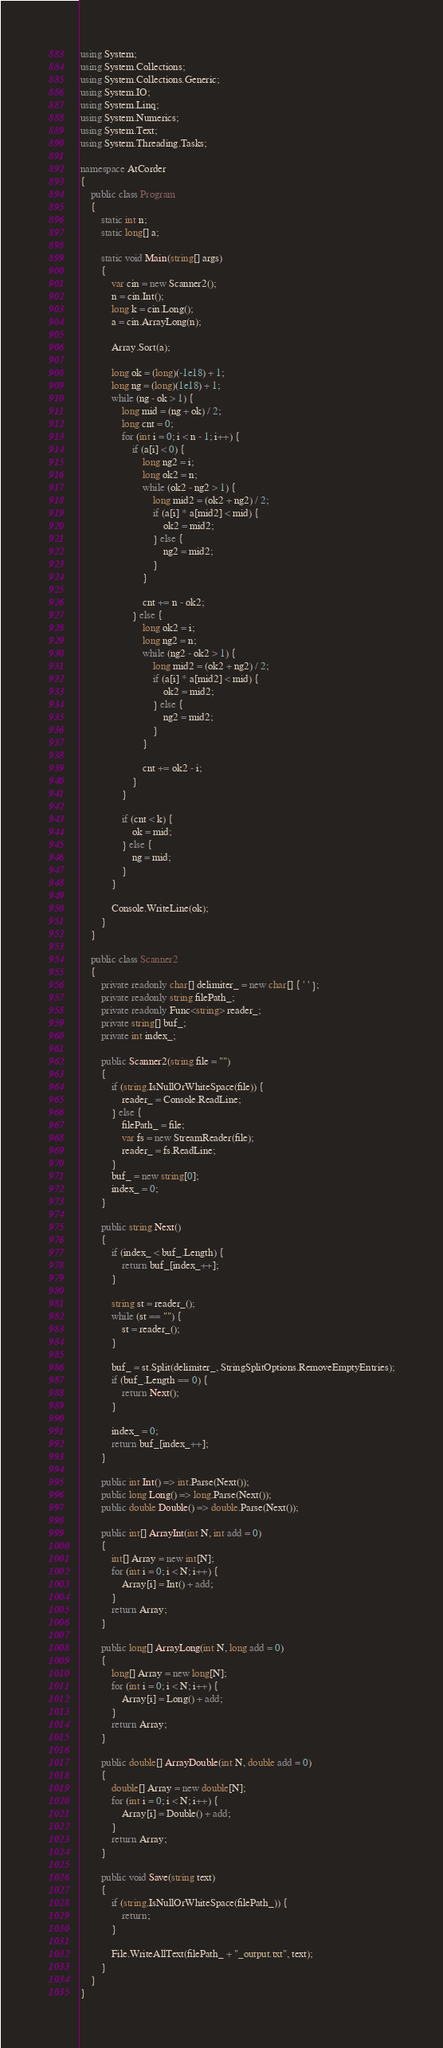<code> <loc_0><loc_0><loc_500><loc_500><_C#_>using System;
using System.Collections;
using System.Collections.Generic;
using System.IO;
using System.Linq;
using System.Numerics;
using System.Text;
using System.Threading.Tasks;

namespace AtCorder
{
	public class Program
	{
		static int n;
		static long[] a;

		static void Main(string[] args)
		{
			var cin = new Scanner2();
			n = cin.Int();
			long k = cin.Long();
			a = cin.ArrayLong(n);

			Array.Sort(a);

			long ok = (long)(-1e18) + 1;
			long ng = (long)(1e18) + 1;
			while (ng - ok > 1) {
				long mid = (ng + ok) / 2;
				long cnt = 0;
				for (int i = 0; i < n - 1; i++) {
					if (a[i] < 0) {
						long ng2 = i;
						long ok2 = n;
						while (ok2 - ng2 > 1) {
							long mid2 = (ok2 + ng2) / 2;
							if (a[i] * a[mid2] < mid) {
								ok2 = mid2;
							} else {
								ng2 = mid2;
							}
						}

						cnt += n - ok2;
					} else {
						long ok2 = i;
						long ng2 = n;
						while (ng2 - ok2 > 1) {
							long mid2 = (ok2 + ng2) / 2;
							if (a[i] * a[mid2] < mid) {
								ok2 = mid2;
							} else {
								ng2 = mid2;
							}
						}

						cnt += ok2 - i;
					}
				}

				if (cnt < k) {
					ok = mid;
				} else {
					ng = mid;
				}
			}

			Console.WriteLine(ok);
		}
	}

	public class Scanner2
	{
		private readonly char[] delimiter_ = new char[] { ' ' };
		private readonly string filePath_;
		private readonly Func<string> reader_;
		private string[] buf_;
		private int index_;

		public Scanner2(string file = "")
		{
			if (string.IsNullOrWhiteSpace(file)) {
				reader_ = Console.ReadLine;
			} else {
				filePath_ = file;
				var fs = new StreamReader(file);
				reader_ = fs.ReadLine;
			}
			buf_ = new string[0];
			index_ = 0;
		}

		public string Next()
		{
			if (index_ < buf_.Length) {
				return buf_[index_++];
			}

			string st = reader_();
			while (st == "") {
				st = reader_();
			}

			buf_ = st.Split(delimiter_, StringSplitOptions.RemoveEmptyEntries);
			if (buf_.Length == 0) {
				return Next();
			}

			index_ = 0;
			return buf_[index_++];
		}

		public int Int() => int.Parse(Next());
		public long Long() => long.Parse(Next());
		public double Double() => double.Parse(Next());

		public int[] ArrayInt(int N, int add = 0)
		{
			int[] Array = new int[N];
			for (int i = 0; i < N; i++) {
				Array[i] = Int() + add;
			}
			return Array;
		}

		public long[] ArrayLong(int N, long add = 0)
		{
			long[] Array = new long[N];
			for (int i = 0; i < N; i++) {
				Array[i] = Long() + add;
			}
			return Array;
		}

		public double[] ArrayDouble(int N, double add = 0)
		{
			double[] Array = new double[N];
			for (int i = 0; i < N; i++) {
				Array[i] = Double() + add;
			}
			return Array;
		}

		public void Save(string text)
		{
			if (string.IsNullOrWhiteSpace(filePath_)) {
				return;
			}

			File.WriteAllText(filePath_ + "_output.txt", text);
		}
	}
}</code> 